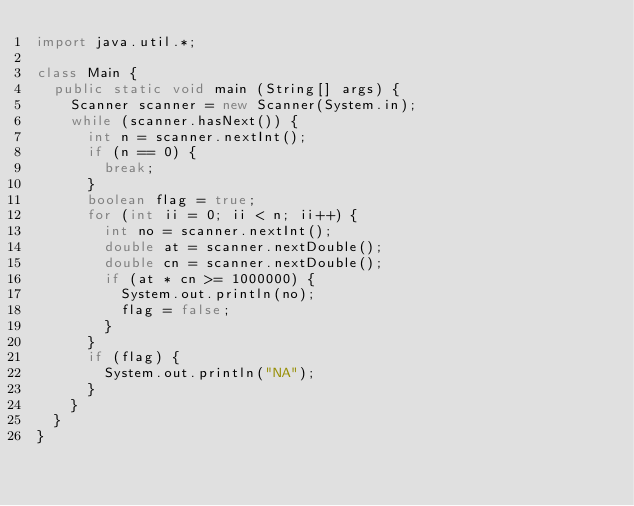Convert code to text. <code><loc_0><loc_0><loc_500><loc_500><_Java_>import java.util.*;

class Main {
  public static void main (String[] args) {
    Scanner scanner = new Scanner(System.in);
    while (scanner.hasNext()) {
      int n = scanner.nextInt();
      if (n == 0) {
        break;
      }
      boolean flag = true;
      for (int ii = 0; ii < n; ii++) {
        int no = scanner.nextInt();
        double at = scanner.nextDouble();
        double cn = scanner.nextDouble();
        if (at * cn >= 1000000) {
          System.out.println(no);
          flag = false;
        }
      }
      if (flag) {
        System.out.println("NA");
      }
    }
  }
}</code> 